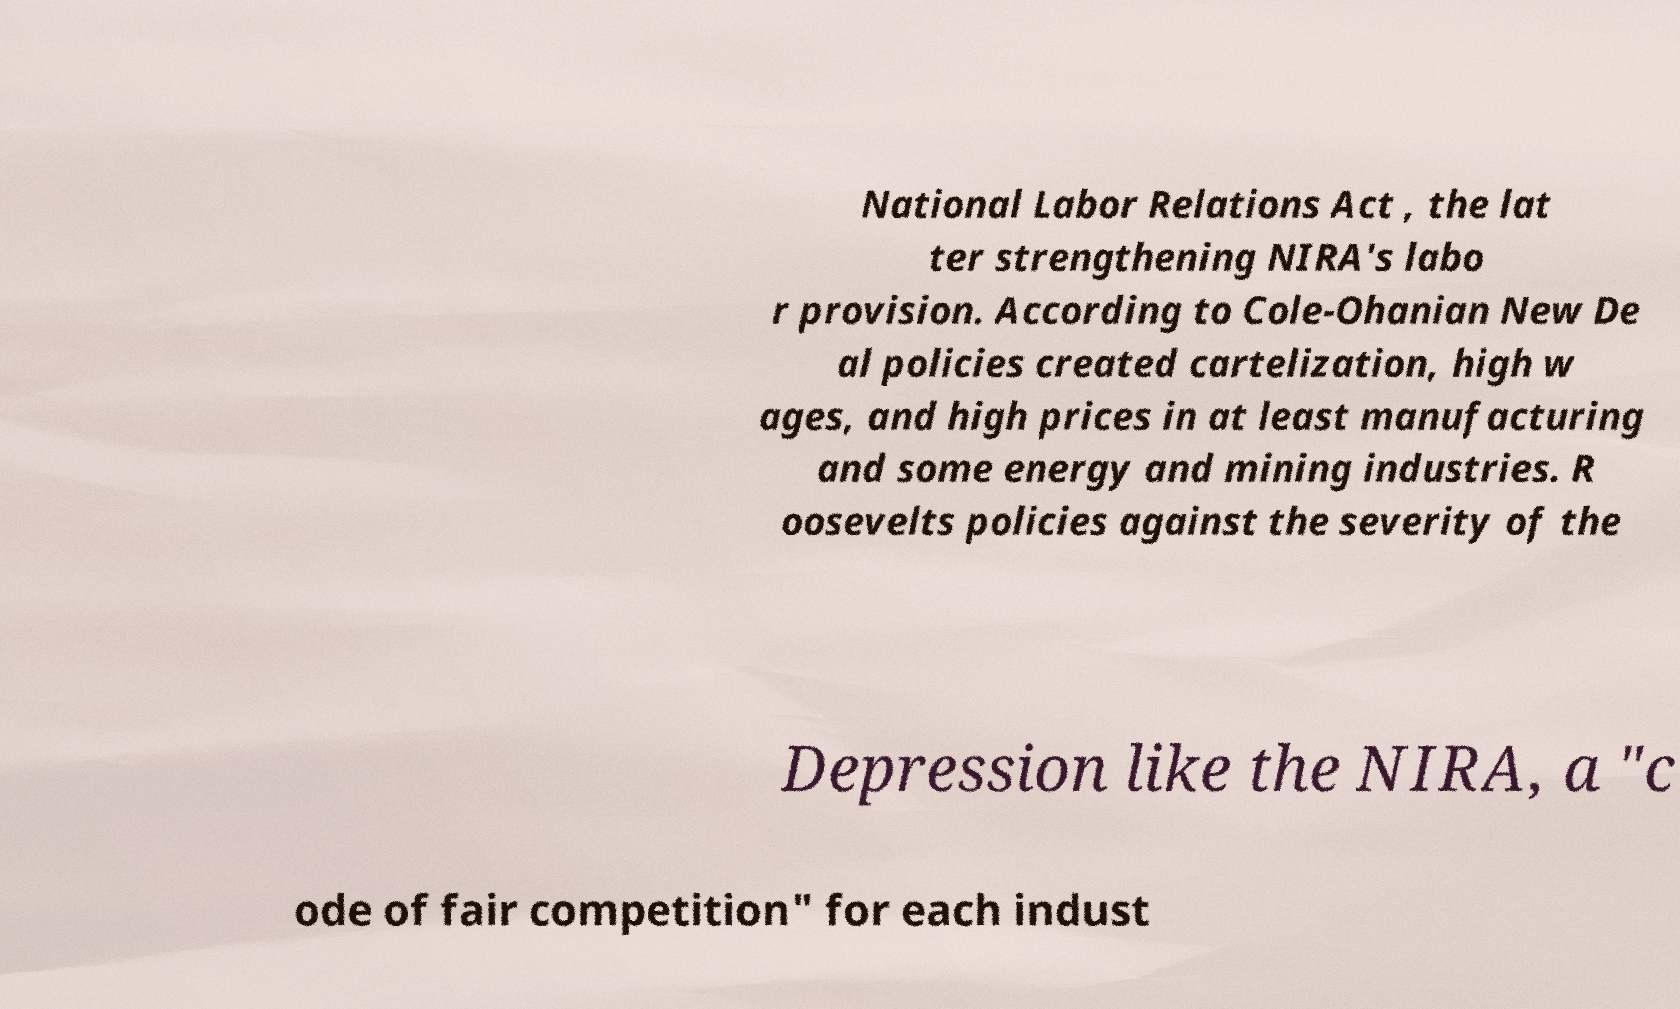Can you accurately transcribe the text from the provided image for me? National Labor Relations Act , the lat ter strengthening NIRA's labo r provision. According to Cole-Ohanian New De al policies created cartelization, high w ages, and high prices in at least manufacturing and some energy and mining industries. R oosevelts policies against the severity of the Depression like the NIRA, a "c ode of fair competition" for each indust 